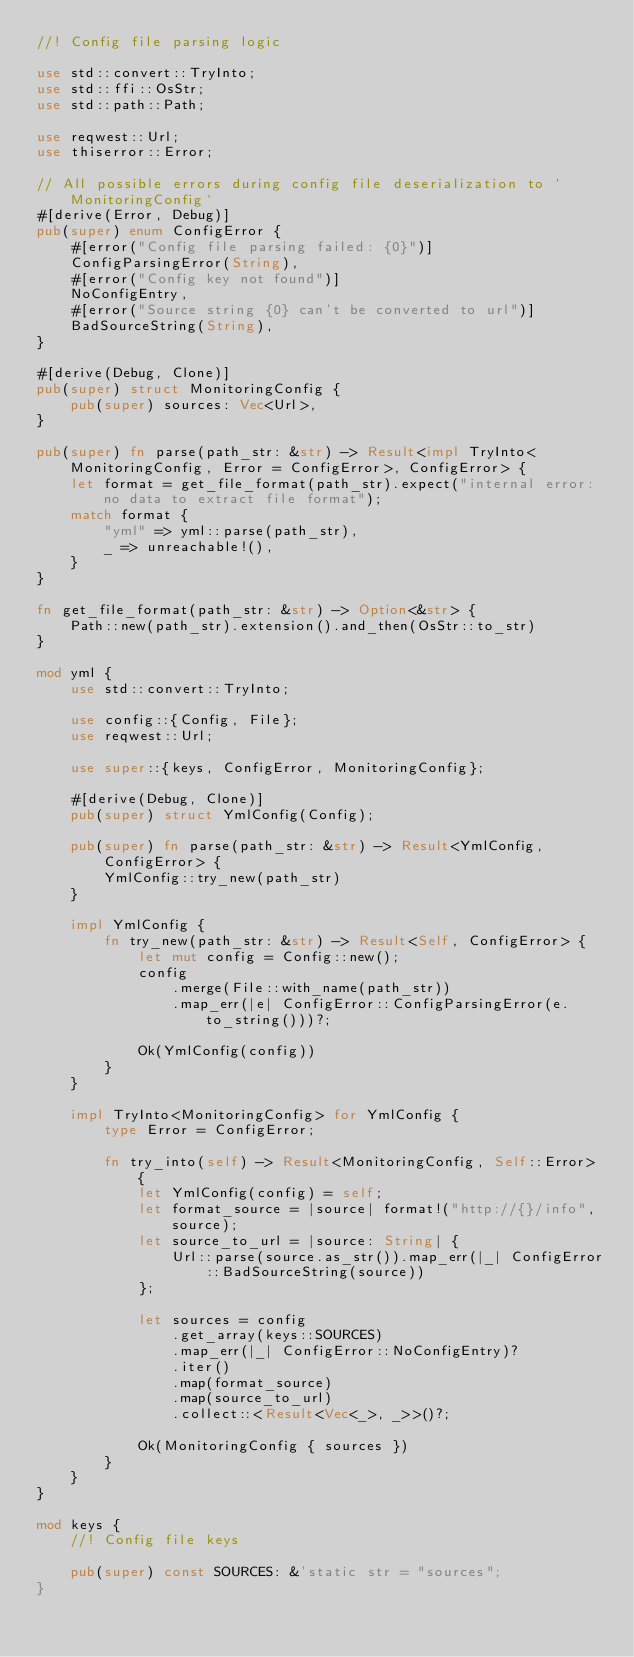<code> <loc_0><loc_0><loc_500><loc_500><_Rust_>//! Config file parsing logic

use std::convert::TryInto;
use std::ffi::OsStr;
use std::path::Path;

use reqwest::Url;
use thiserror::Error;

// All possible errors during config file deserialization to `MonitoringConfig`
#[derive(Error, Debug)]
pub(super) enum ConfigError {
    #[error("Config file parsing failed: {0}")]
    ConfigParsingError(String),
    #[error("Config key not found")]
    NoConfigEntry,
    #[error("Source string {0} can't be converted to url")]
    BadSourceString(String),
}

#[derive(Debug, Clone)]
pub(super) struct MonitoringConfig {
    pub(super) sources: Vec<Url>,
}

pub(super) fn parse(path_str: &str) -> Result<impl TryInto<MonitoringConfig, Error = ConfigError>, ConfigError> {
    let format = get_file_format(path_str).expect("internal error: no data to extract file format");
    match format {
        "yml" => yml::parse(path_str),
        _ => unreachable!(),
    }
}

fn get_file_format(path_str: &str) -> Option<&str> {
    Path::new(path_str).extension().and_then(OsStr::to_str)
}

mod yml {
    use std::convert::TryInto;

    use config::{Config, File};
    use reqwest::Url;

    use super::{keys, ConfigError, MonitoringConfig};

    #[derive(Debug, Clone)]
    pub(super) struct YmlConfig(Config);

    pub(super) fn parse(path_str: &str) -> Result<YmlConfig, ConfigError> {
        YmlConfig::try_new(path_str)
    }

    impl YmlConfig {
        fn try_new(path_str: &str) -> Result<Self, ConfigError> {
            let mut config = Config::new();
            config
                .merge(File::with_name(path_str))
                .map_err(|e| ConfigError::ConfigParsingError(e.to_string()))?;

            Ok(YmlConfig(config))
        }
    }

    impl TryInto<MonitoringConfig> for YmlConfig {
        type Error = ConfigError;

        fn try_into(self) -> Result<MonitoringConfig, Self::Error> {
            let YmlConfig(config) = self;
            let format_source = |source| format!("http://{}/info", source);
            let source_to_url = |source: String| {
                Url::parse(source.as_str()).map_err(|_| ConfigError::BadSourceString(source))
            };

            let sources = config
                .get_array(keys::SOURCES)
                .map_err(|_| ConfigError::NoConfigEntry)?
                .iter()
                .map(format_source)
                .map(source_to_url)
                .collect::<Result<Vec<_>, _>>()?;

            Ok(MonitoringConfig { sources })
        }
    }
}

mod keys {
    //! Config file keys

    pub(super) const SOURCES: &'static str = "sources";
}
</code> 